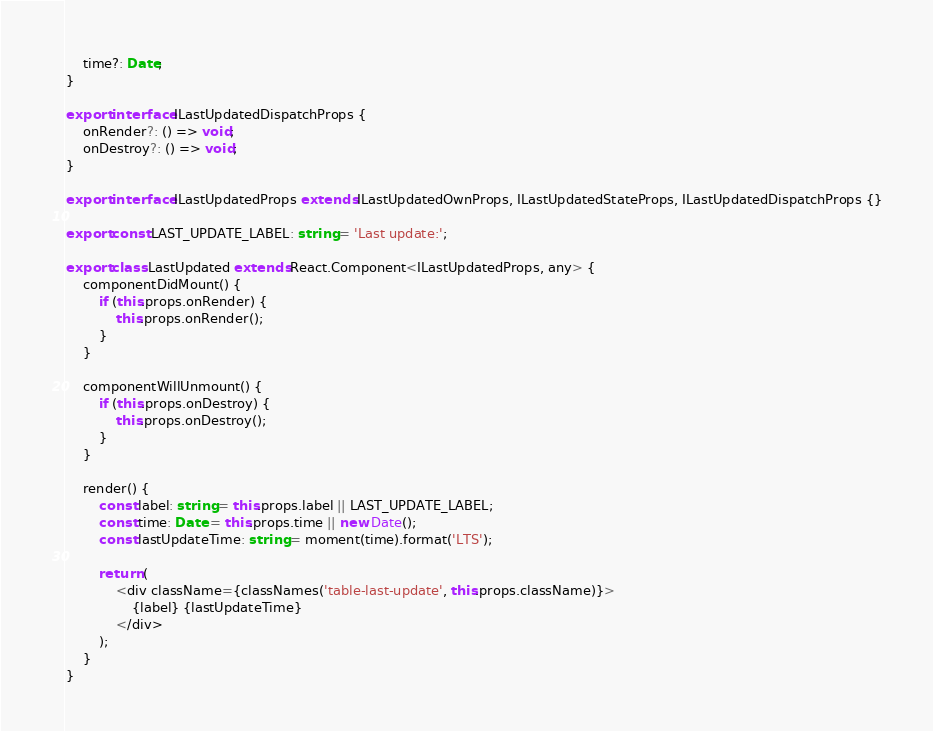Convert code to text. <code><loc_0><loc_0><loc_500><loc_500><_TypeScript_>    time?: Date;
}

export interface ILastUpdatedDispatchProps {
    onRender?: () => void;
    onDestroy?: () => void;
}

export interface ILastUpdatedProps extends ILastUpdatedOwnProps, ILastUpdatedStateProps, ILastUpdatedDispatchProps {}

export const LAST_UPDATE_LABEL: string = 'Last update:';

export class LastUpdated extends React.Component<ILastUpdatedProps, any> {
    componentDidMount() {
        if (this.props.onRender) {
            this.props.onRender();
        }
    }

    componentWillUnmount() {
        if (this.props.onDestroy) {
            this.props.onDestroy();
        }
    }

    render() {
        const label: string = this.props.label || LAST_UPDATE_LABEL;
        const time: Date = this.props.time || new Date();
        const lastUpdateTime: string = moment(time).format('LTS');

        return (
            <div className={classNames('table-last-update', this.props.className)}>
                {label} {lastUpdateTime}
            </div>
        );
    }
}
</code> 